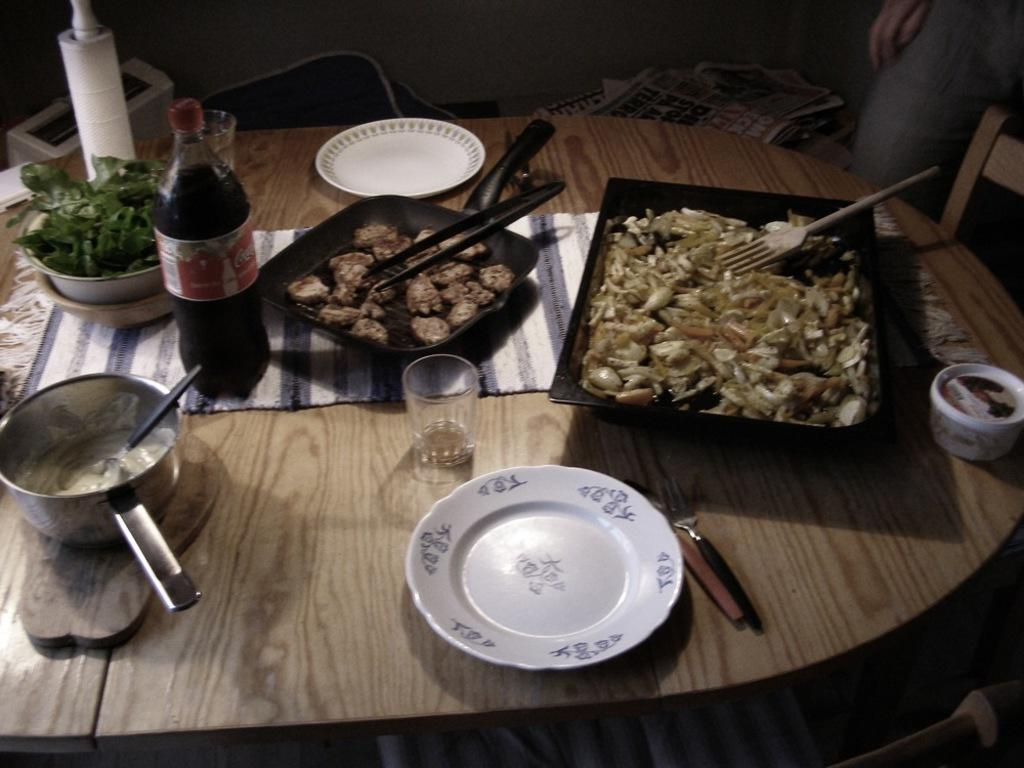What piece of furniture is present in the image? There is a table in the image. What items are placed on the table? There are plates, a bowl, and a bottle on the table. What type of food can be seen on the table? There is food visible on the table. How many times does the roll appear in the image? There is no roll present in the image. Where can the rest be found in the image? The term "rest" is not mentioned in the image, so it cannot be found. 